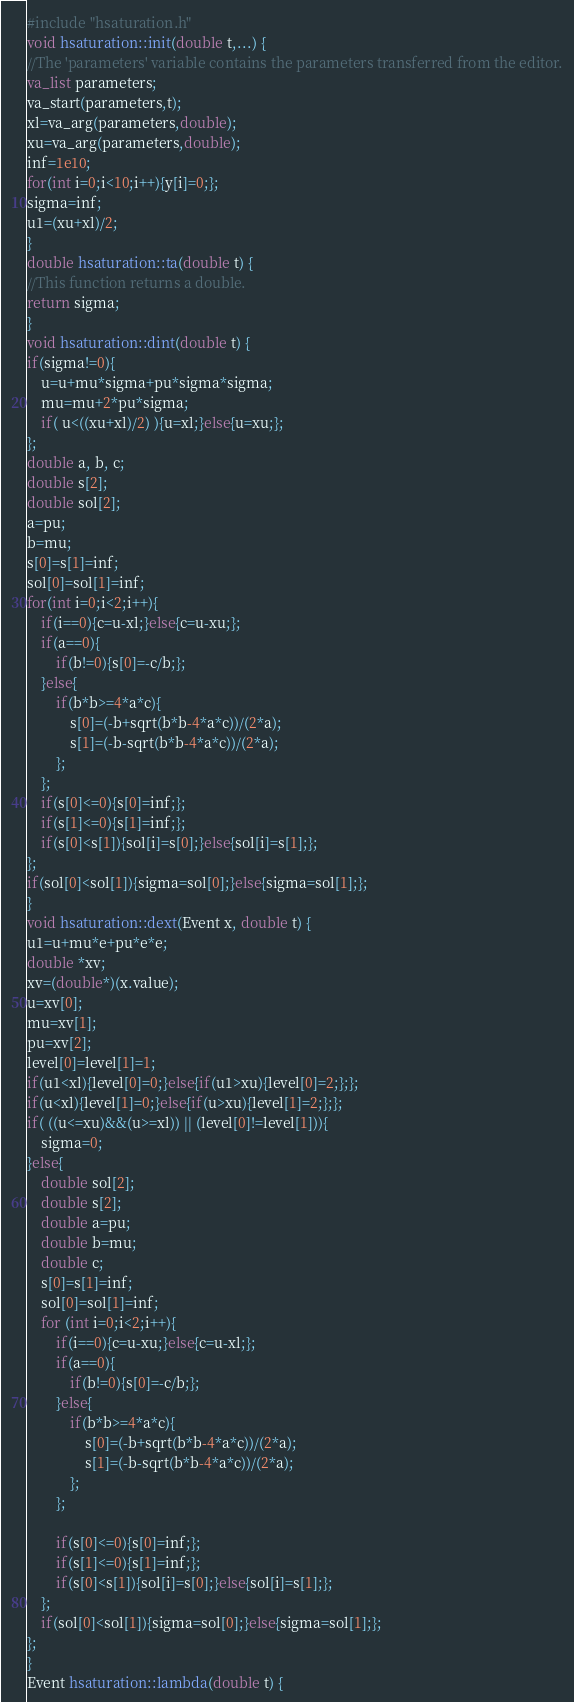<code> <loc_0><loc_0><loc_500><loc_500><_C++_>#include "hsaturation.h"
void hsaturation::init(double t,...) {
//The 'parameters' variable contains the parameters transferred from the editor.
va_list parameters;
va_start(parameters,t);
xl=va_arg(parameters,double);
xu=va_arg(parameters,double);
inf=1e10;
for(int i=0;i<10;i++){y[i]=0;};
sigma=inf;
u1=(xu+xl)/2;
}
double hsaturation::ta(double t) {
//This function returns a double.
return sigma;
}
void hsaturation::dint(double t) {
if(sigma!=0){
	u=u+mu*sigma+pu*sigma*sigma;
	mu=mu+2*pu*sigma;
	if( u<((xu+xl)/2) ){u=xl;}else{u=xu;};
};
double a, b, c;
double s[2];
double sol[2];
a=pu;
b=mu;
s[0]=s[1]=inf;
sol[0]=sol[1]=inf;
for(int i=0;i<2;i++){
	if(i==0){c=u-xl;}else{c=u-xu;};
	if(a==0){
		if(b!=0){s[0]=-c/b;};
	}else{
		if(b*b>=4*a*c){
			s[0]=(-b+sqrt(b*b-4*a*c))/(2*a);
			s[1]=(-b-sqrt(b*b-4*a*c))/(2*a);
		};
	};
	if(s[0]<=0){s[0]=inf;};
	if(s[1]<=0){s[1]=inf;};
	if(s[0]<s[1]){sol[i]=s[0];}else{sol[i]=s[1];};
};
if(sol[0]<sol[1]){sigma=sol[0];}else{sigma=sol[1];};
}
void hsaturation::dext(Event x, double t) {
u1=u+mu*e+pu*e*e;
double *xv;
xv=(double*)(x.value);
u=xv[0];
mu=xv[1];
pu=xv[2];
level[0]=level[1]=1;
if(u1<xl){level[0]=0;}else{if(u1>xu){level[0]=2;};};
if(u<xl){level[1]=0;}else{if(u>xu){level[1]=2;};};
if( ((u<=xu)&&(u>=xl)) || (level[0]!=level[1])){
	sigma=0;
}else{
	double sol[2];
	double s[2];
	double a=pu;
	double b=mu;
	double c;	
	s[0]=s[1]=inf;
	sol[0]=sol[1]=inf;
	for (int i=0;i<2;i++){
		if(i==0){c=u-xu;}else{c=u-xl;};
		if(a==0){
			if(b!=0){s[0]=-c/b;};
		}else{
			if(b*b>=4*a*c){
				s[0]=(-b+sqrt(b*b-4*a*c))/(2*a);
				s[1]=(-b-sqrt(b*b-4*a*c))/(2*a);
			};
		};
	
		if(s[0]<=0){s[0]=inf;};
		if(s[1]<=0){s[1]=inf;};
		if(s[0]<s[1]){sol[i]=s[0];}else{sol[i]=s[1];};	
	}; 
	if(sol[0]<sol[1]){sigma=sol[0];}else{sigma=sol[1];};
};
}
Event hsaturation::lambda(double t) {</code> 